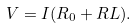<formula> <loc_0><loc_0><loc_500><loc_500>V = I ( R _ { 0 } + R L ) .</formula> 